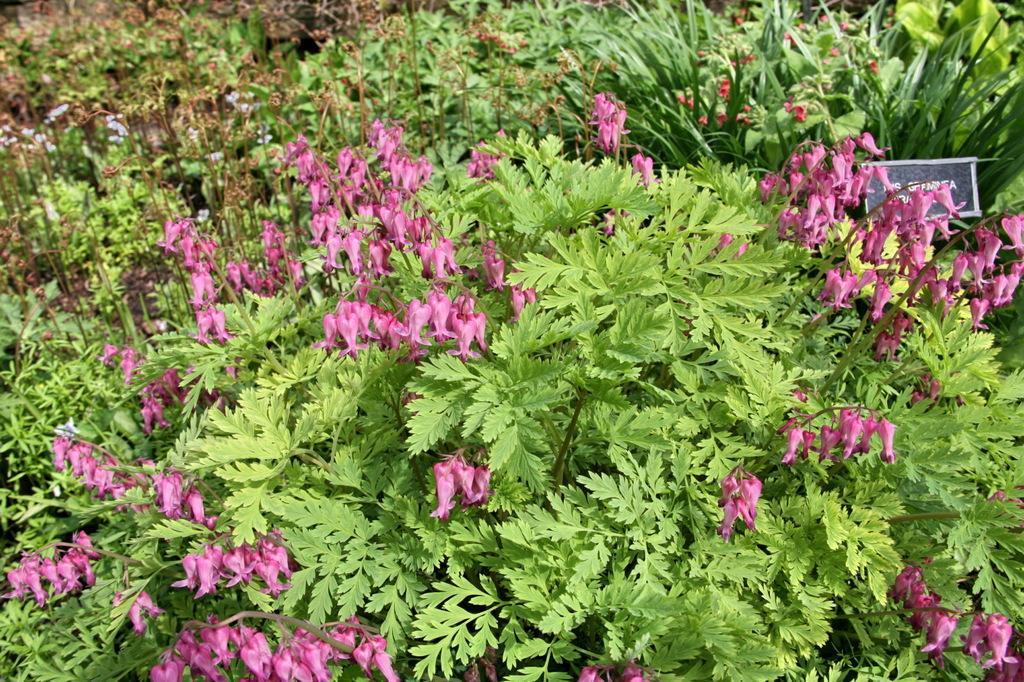Could you give a brief overview of what you see in this image? In this image there are some plants and flowers, on the right side there is one board. 